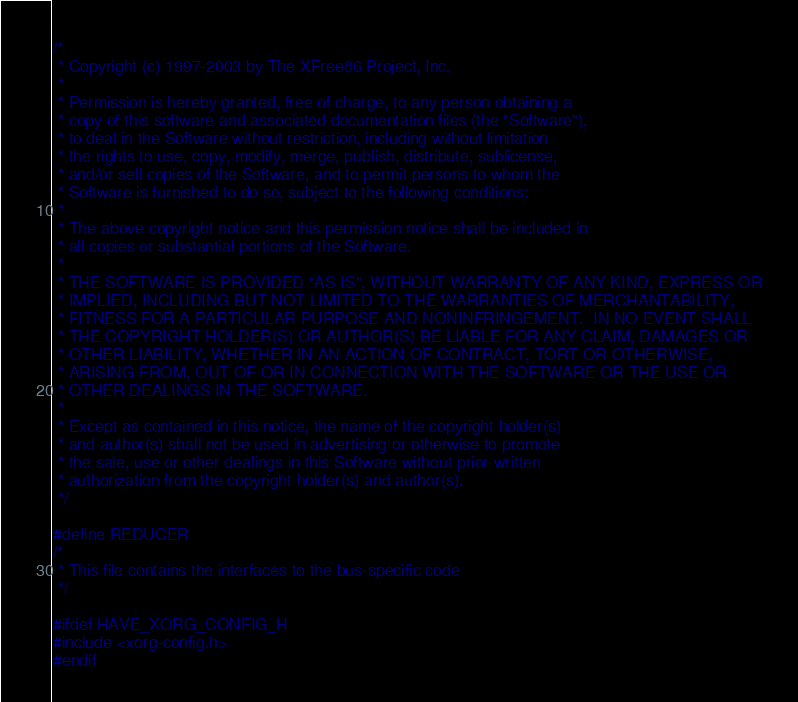<code> <loc_0><loc_0><loc_500><loc_500><_C_>/*
 * Copyright (c) 1997-2003 by The XFree86 Project, Inc.
 *
 * Permission is hereby granted, free of charge, to any person obtaining a
 * copy of this software and associated documentation files (the "Software"),
 * to deal in the Software without restriction, including without limitation
 * the rights to use, copy, modify, merge, publish, distribute, sublicense,
 * and/or sell copies of the Software, and to permit persons to whom the
 * Software is furnished to do so, subject to the following conditions:
 *
 * The above copyright notice and this permission notice shall be included in
 * all copies or substantial portions of the Software.
 *
 * THE SOFTWARE IS PROVIDED "AS IS", WITHOUT WARRANTY OF ANY KIND, EXPRESS OR
 * IMPLIED, INCLUDING BUT NOT LIMITED TO THE WARRANTIES OF MERCHANTABILITY,
 * FITNESS FOR A PARTICULAR PURPOSE AND NONINFRINGEMENT.  IN NO EVENT SHALL
 * THE COPYRIGHT HOLDER(S) OR AUTHOR(S) BE LIABLE FOR ANY CLAIM, DAMAGES OR
 * OTHER LIABILITY, WHETHER IN AN ACTION OF CONTRACT, TORT OR OTHERWISE,
 * ARISING FROM, OUT OF OR IN CONNECTION WITH THE SOFTWARE OR THE USE OR
 * OTHER DEALINGS IN THE SOFTWARE.
 *
 * Except as contained in this notice, the name of the copyright holder(s)
 * and author(s) shall not be used in advertising or otherwise to promote
 * the sale, use or other dealings in this Software without prior written
 * authorization from the copyright holder(s) and author(s).
 */

#define REDUCER
/*
 * This file contains the interfaces to the bus-specific code
 */

#ifdef HAVE_XORG_CONFIG_H
#include <xorg-config.h>
#endif
</code> 